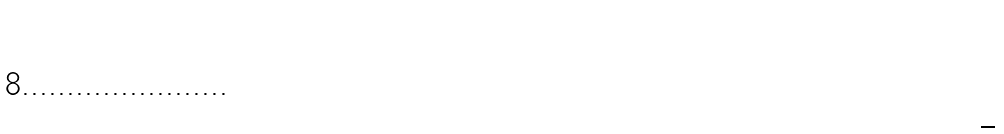Convert formula to latex. <formula><loc_0><loc_0><loc_500><loc_500>\begin{matrix} 0 \\ 0 \\ \frac { 1 } { 2 } \end{matrix}</formula> 